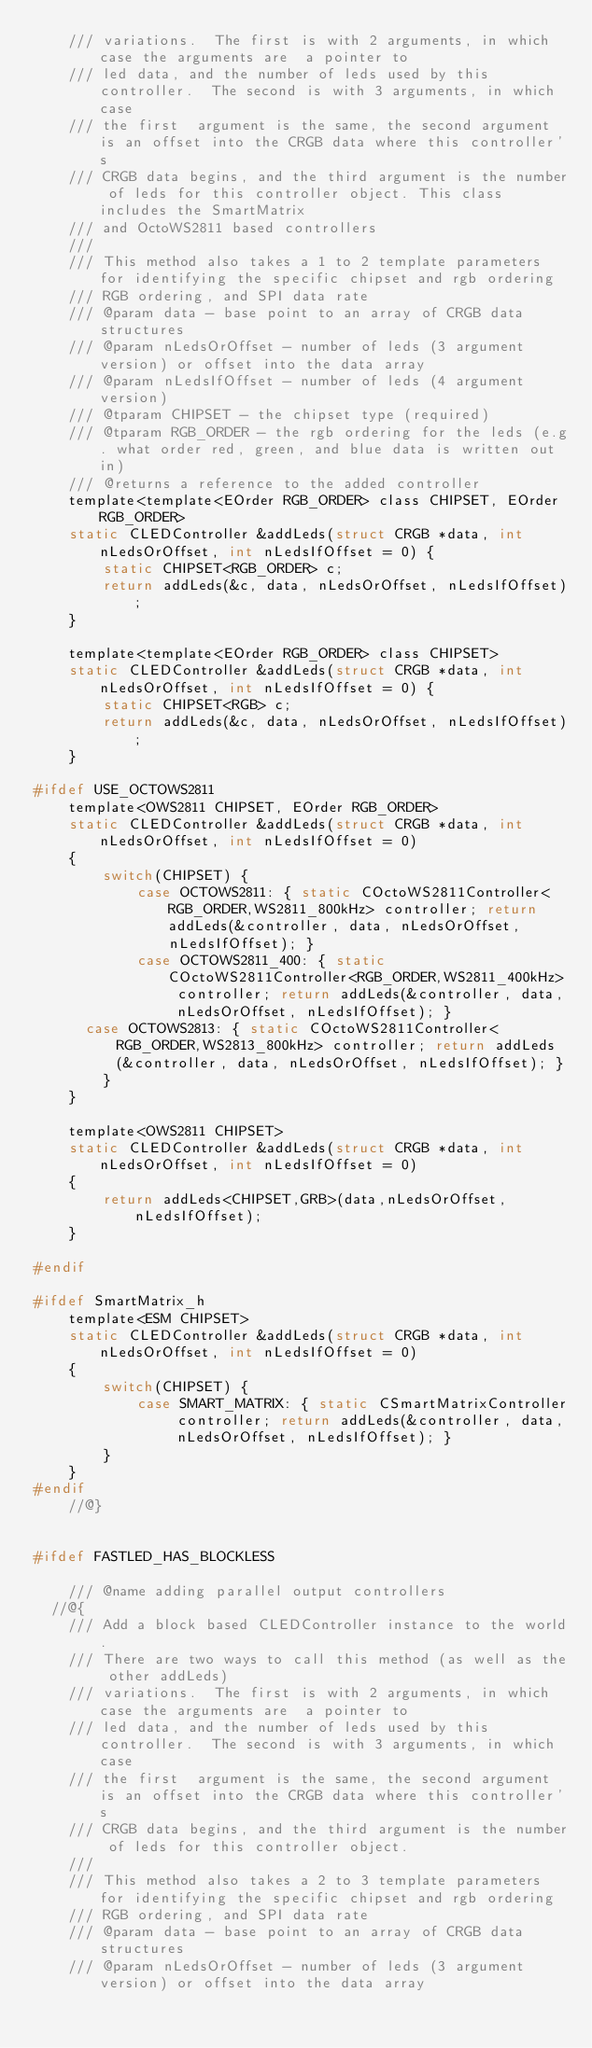<code> <loc_0><loc_0><loc_500><loc_500><_C_>	/// variations.  The first is with 2 arguments, in which case the arguments are  a pointer to
	/// led data, and the number of leds used by this controller.  The second is with 3 arguments, in which case
	/// the first  argument is the same, the second argument is an offset into the CRGB data where this controller's
	/// CRGB data begins, and the third argument is the number of leds for this controller object. This class includes the SmartMatrix
	/// and OctoWS2811 based controllers
	///
	/// This method also takes a 1 to 2 template parameters for identifying the specific chipset and rgb ordering
	/// RGB ordering, and SPI data rate
	/// @param data - base point to an array of CRGB data structures
	/// @param nLedsOrOffset - number of leds (3 argument version) or offset into the data array
	/// @param nLedsIfOffset - number of leds (4 argument version)
	/// @tparam CHIPSET - the chipset type (required)
	/// @tparam RGB_ORDER - the rgb ordering for the leds (e.g. what order red, green, and blue data is written out in)
	/// @returns a reference to the added controller
	template<template<EOrder RGB_ORDER> class CHIPSET, EOrder RGB_ORDER>
	static CLEDController &addLeds(struct CRGB *data, int nLedsOrOffset, int nLedsIfOffset = 0) {
		static CHIPSET<RGB_ORDER> c;
		return addLeds(&c, data, nLedsOrOffset, nLedsIfOffset);
	}

	template<template<EOrder RGB_ORDER> class CHIPSET>
	static CLEDController &addLeds(struct CRGB *data, int nLedsOrOffset, int nLedsIfOffset = 0) {
		static CHIPSET<RGB> c;
		return addLeds(&c, data, nLedsOrOffset, nLedsIfOffset);
	}

#ifdef USE_OCTOWS2811
	template<OWS2811 CHIPSET, EOrder RGB_ORDER>
	static CLEDController &addLeds(struct CRGB *data, int nLedsOrOffset, int nLedsIfOffset = 0)
	{
		switch(CHIPSET) {
			case OCTOWS2811: { static COctoWS2811Controller<RGB_ORDER,WS2811_800kHz> controller; return addLeds(&controller, data, nLedsOrOffset, nLedsIfOffset); }
			case OCTOWS2811_400: { static COctoWS2811Controller<RGB_ORDER,WS2811_400kHz> controller; return addLeds(&controller, data, nLedsOrOffset, nLedsIfOffset); }
      case OCTOWS2813: { static COctoWS2811Controller<RGB_ORDER,WS2813_800kHz> controller; return addLeds(&controller, data, nLedsOrOffset, nLedsIfOffset); }
		}
	}

	template<OWS2811 CHIPSET>
	static CLEDController &addLeds(struct CRGB *data, int nLedsOrOffset, int nLedsIfOffset = 0)
	{
		return addLeds<CHIPSET,GRB>(data,nLedsOrOffset,nLedsIfOffset);
	}

#endif

#ifdef SmartMatrix_h
	template<ESM CHIPSET>
	static CLEDController &addLeds(struct CRGB *data, int nLedsOrOffset, int nLedsIfOffset = 0)
	{
		switch(CHIPSET) {
			case SMART_MATRIX: { static CSmartMatrixController controller; return addLeds(&controller, data, nLedsOrOffset, nLedsIfOffset); }
		}
	}
#endif
	//@}


#ifdef FASTLED_HAS_BLOCKLESS

	/// @name adding parallel output controllers
  //@{
	/// Add a block based CLEDController instance to the world.
	/// There are two ways to call this method (as well as the other addLeds)
	/// variations.  The first is with 2 arguments, in which case the arguments are  a pointer to
	/// led data, and the number of leds used by this controller.  The second is with 3 arguments, in which case
	/// the first  argument is the same, the second argument is an offset into the CRGB data where this controller's
	/// CRGB data begins, and the third argument is the number of leds for this controller object.
	///
	/// This method also takes a 2 to 3 template parameters for identifying the specific chipset and rgb ordering
	/// RGB ordering, and SPI data rate
	/// @param data - base point to an array of CRGB data structures
	/// @param nLedsOrOffset - number of leds (3 argument version) or offset into the data array</code> 